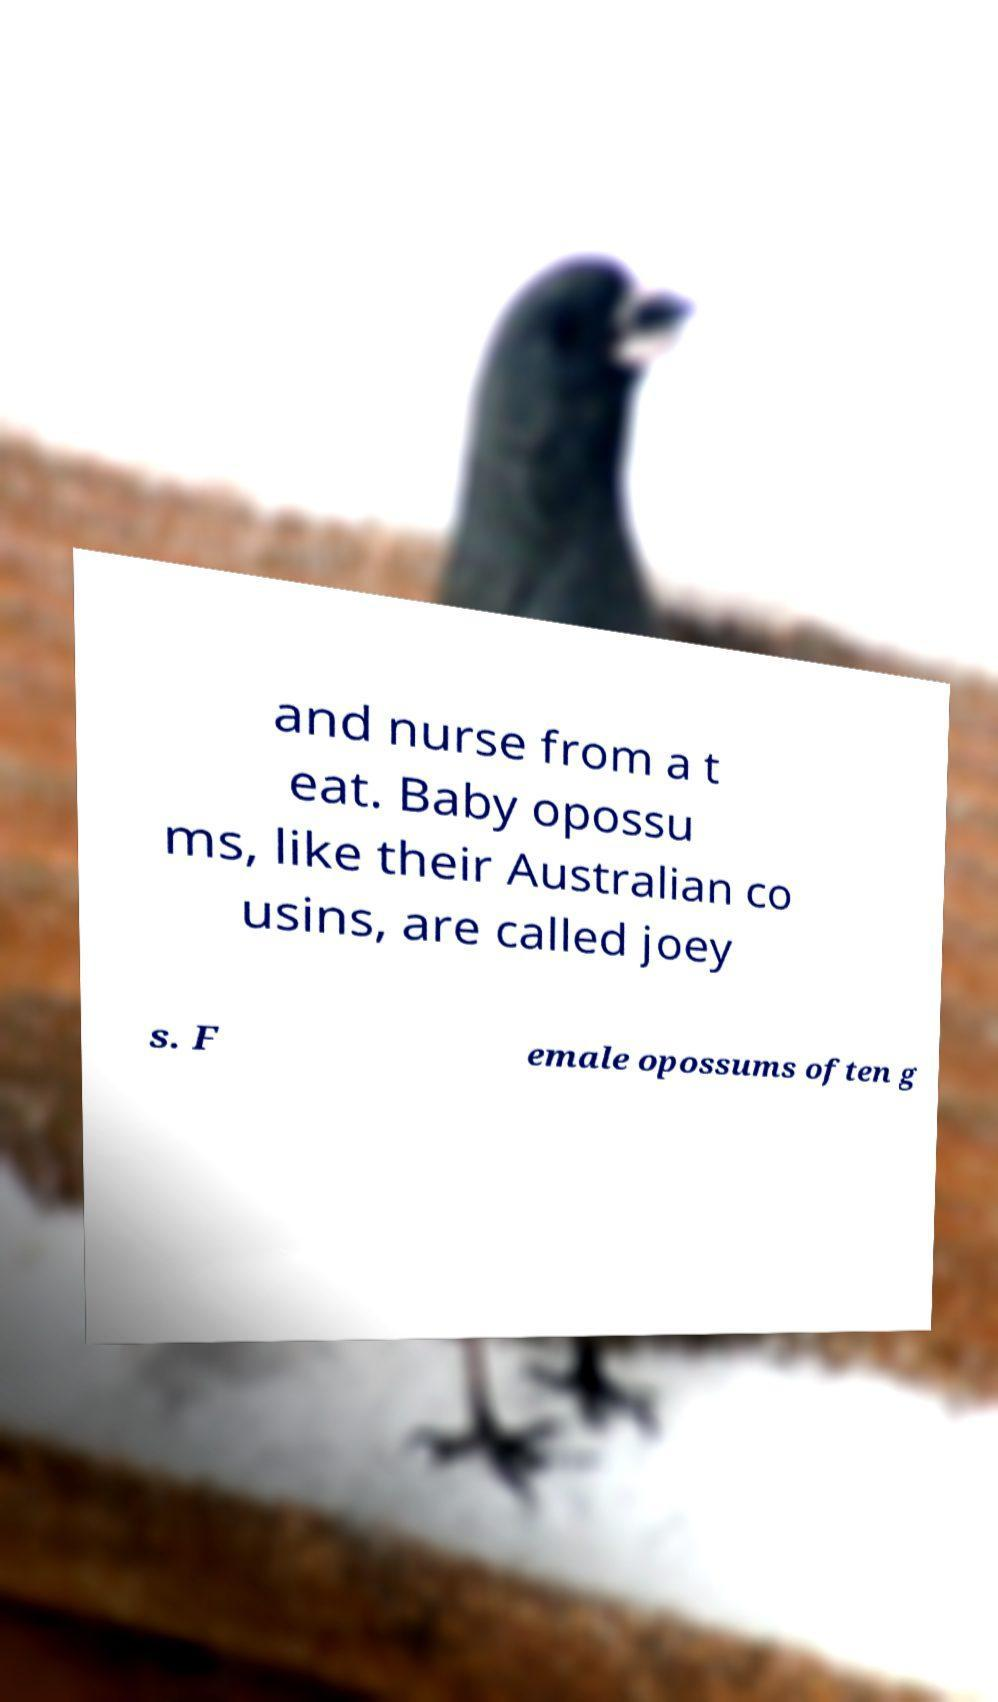Could you assist in decoding the text presented in this image and type it out clearly? and nurse from a t eat. Baby opossu ms, like their Australian co usins, are called joey s. F emale opossums often g 